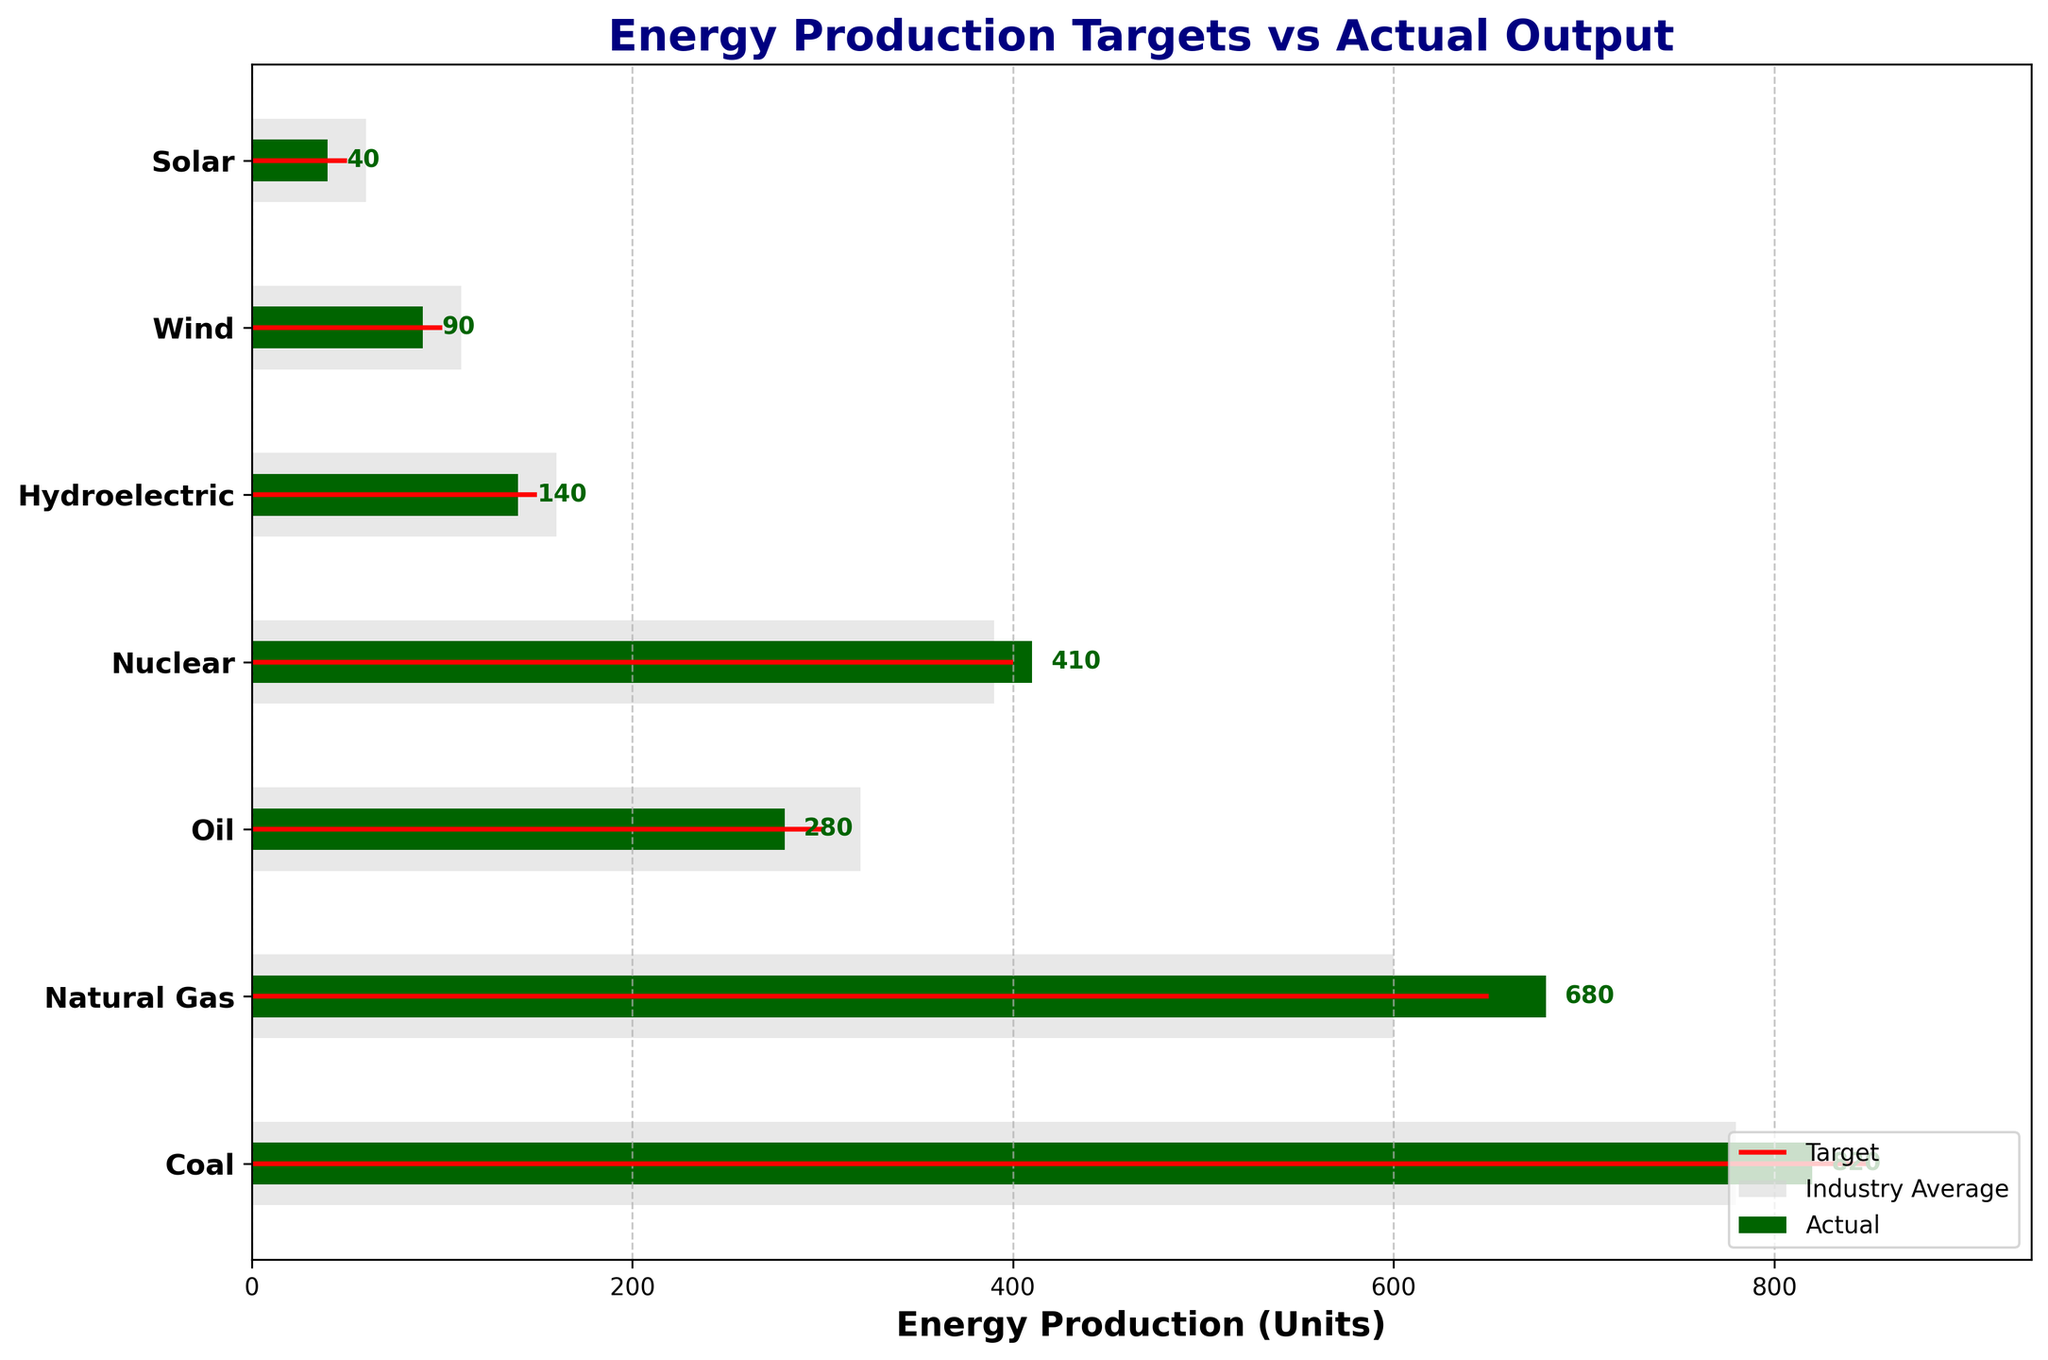what is the title of the figure? The title is displayed at the top of the chart, and it is written in bold navy color: "Energy Production Targets vs Actual Output".
Answer: Energy Production Targets vs Actual Output What is the maximum target value among all fuel types? By looking at the red target lines representing target values, the maximum target is for Coal, which is 850 units.
Answer: 850 What is the difference between the actual and comparative value for Natural Gas? The actual value for Natural Gas is 680 units while the comparative is 600 units. The difference is calculated as 680 - 600 = 80.
Answer: 80 Which fuel type has the least actual output? By observing the dark green bars representing actual outputs, Solar has the least actual output of 40 units.
Answer: Solar Is the actual output greater than the target for any fuel type? By comparing the dark green bars to the red target lines, only Natural Gas has its actual output (680) greater than its target (650).
Answer: Yes, Natural Gas What is the average comparative value across all fuel types? First, sum up all comparative values: 780 (Coal) + 600 (Natural Gas) + 320 (Oil) + 390 (Nuclear) + 160 (Hydroelectric) + 110 (Wind) + 60 (Solar) = 2420. Then, divide by the number of fuel types (7), 2420 / 7 = 345.71.
Answer: 345.71 By how much does the actual nuclear energy production exceed the comparative value? The actual nuclear energy production is 410 units while the comparative value is 390 units. The difference is calculated as 410 - 390 = 20.
Answer: 20 Which fuel type has the largest gap between its target and actual production? For each fuel type, calculate the gap between target and actual production: Coal (850-820=30), Natural Gas (-30), Oil (300-280=20), Nuclear (-10), Hydroelectric (150-140=10), Wind (100-90=10), Solar (50-40=10). Coal has the largest gap of 30 units.
Answer: Coal How does the actual output of Wind compare to its target? The actual output of Wind is 90 units, while the target is 100 units. It's less by 100 - 90 = 10 units.
Answer: Less by 10 units What is the total energy production actual across all fuel types? Sum up the actual values: 820 (Coal) + 680 (Natural Gas) + 280 (Oil) + 410 (Nuclear) + 140 (Hydroelectric) + 90 (Wind) + 40 (Solar) = 2460 units.
Answer: 2460 units 